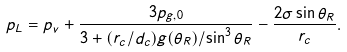<formula> <loc_0><loc_0><loc_500><loc_500>p _ { L } = p _ { v } + \frac { 3 p _ { g , 0 } } { 3 + ( r _ { c } / d _ { c } ) g ( \theta _ { R } ) / \sin ^ { 3 } { \theta _ { R } } } - \frac { 2 \sigma \sin { \theta _ { R } } } { r _ { c } } .</formula> 